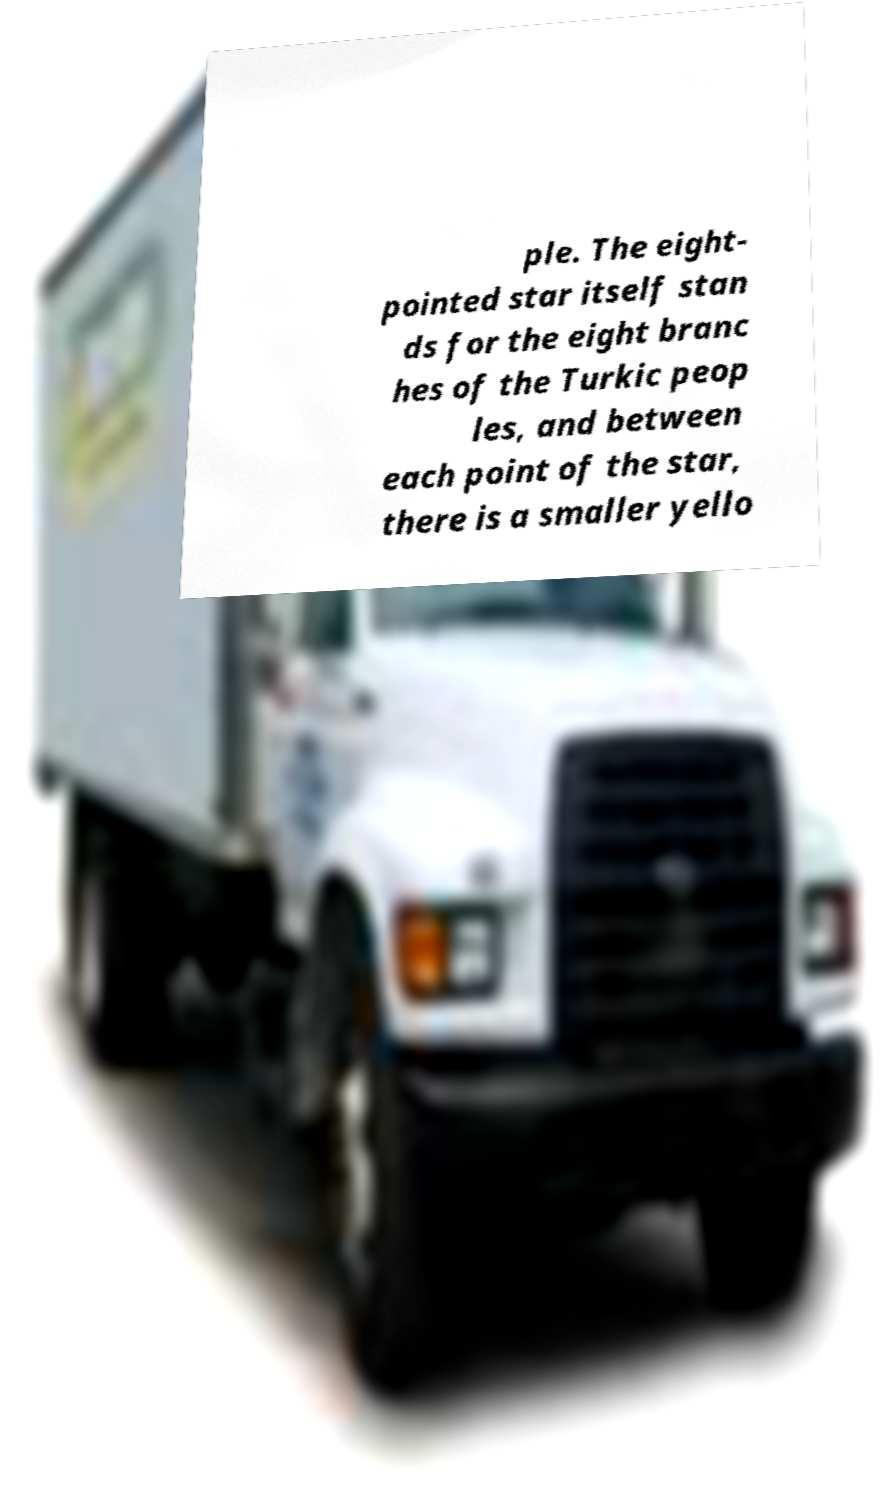What messages or text are displayed in this image? I need them in a readable, typed format. ple. The eight- pointed star itself stan ds for the eight branc hes of the Turkic peop les, and between each point of the star, there is a smaller yello 